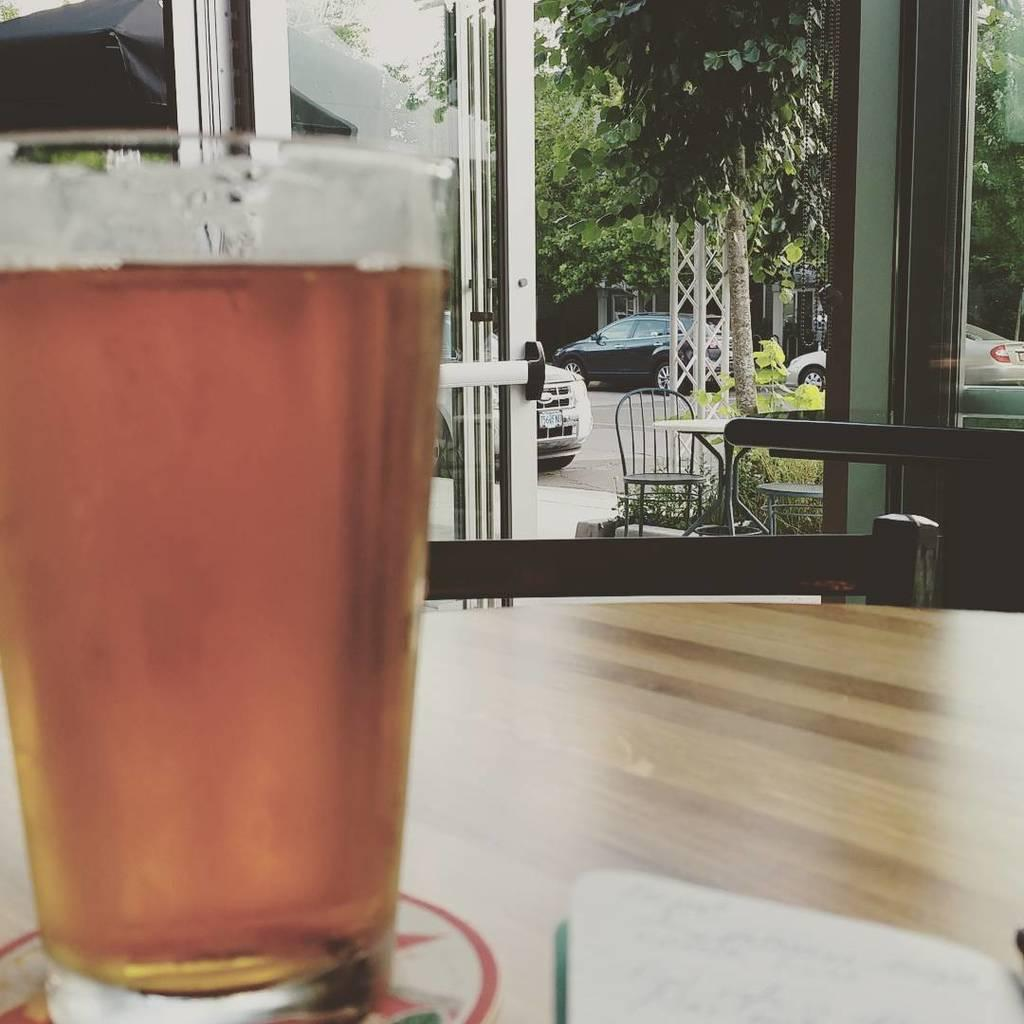What object is on the table in the image? There is a glass on the table in the image. What can be seen in the background of the image? In the background, there is a chair, vehicles, a tree, and a building. How many chairs are visible in the image? There is only one chair visible in the image, which is in the background. How many bulbs are hanging from the tree in the image? There are no bulbs present in the image; the tree is a natural element without any artificial additions. How many girls are visible in the image? There are no girls present in the image; the only human-made object is the chair, and it is unoccupied. 